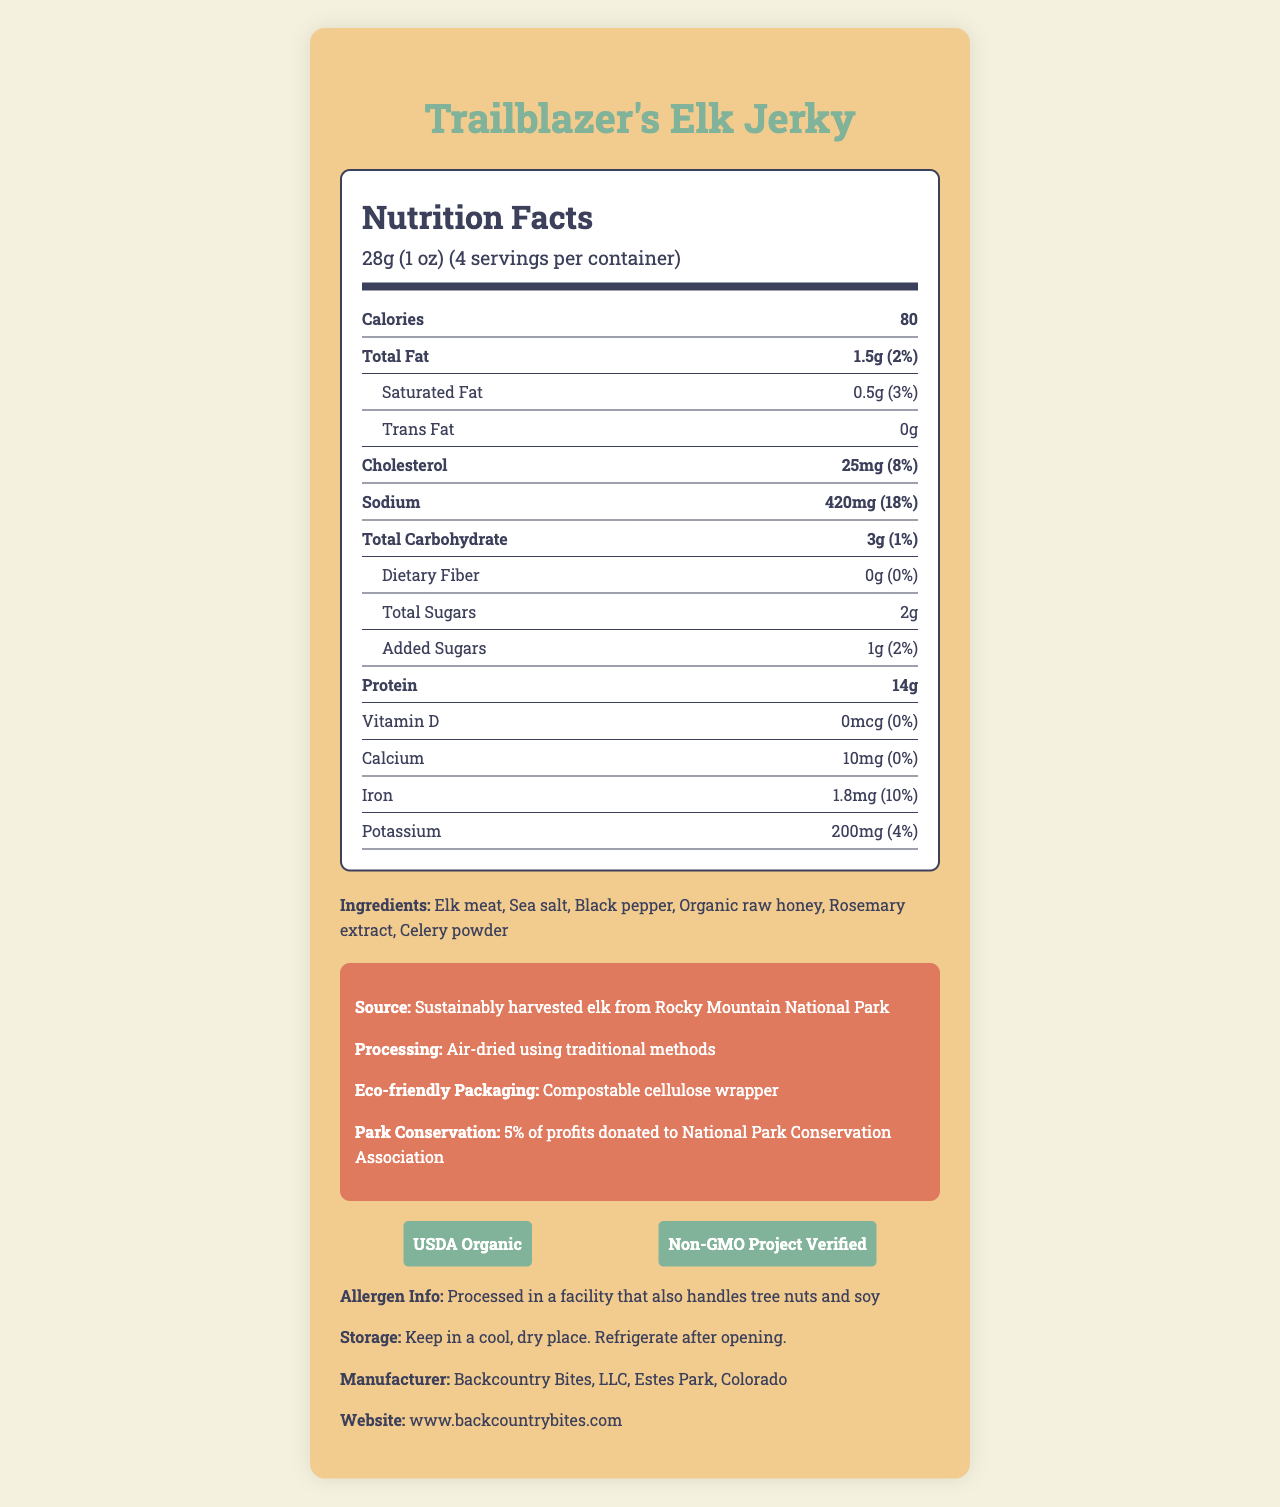What is the serving size for Trailblazer's Elk Jerky? The serving size is indicated in the "Nutrition Facts" section at the top of the label.
Answer: 28g (1 oz) How many calories are in one serving of Trailblazer's Elk Jerky? The number of calories per serving is listed clearly under the "Calories" section.
Answer: 80 What percentage of daily sodium intake does one serving of the jerky represent? This percentage is found under the "Sodium" section in the "Nutrition Facts."
Answer: 18% What is the amount of protein in one serving? The protein content per serving is listed in the "Nutrition Facts" section.
Answer: 14g Name two ingredients included in Trailblazer's Elk Jerky. Ingredients are listed at the end of the "Nutrition Facts" section.
Answer: Elk meat, Sea salt How many servings per container are there? A. 2 B. 4 C. 6 D. 8 The container holds 4 servings, as indicated in the serving size section.
Answer: B Which of the following certifications does Trailblazer's Elk Jerky have? i. USDA Organic ii. Fair Trade iii. Non-GMO Project Verified The jerky is certified USDA Organic and Non-GMO Project Verified, as mentioned in the additional info section.
Answer: i, iii Is there any Vitamin D in Trailblazer's Elk Jerky? Yes/No The Vitamin D amount is listed as 0mcg in the nutrition facts.
Answer: No Summarize what you learn from the additional info about Trailblazer's Elk Jerky. The additional info section provides details about the source, processing method, eco-friendly packaging, and conservation efforts associated with the product.
Answer: The jerky is sourced from sustainably harvested elk from Rocky Mountain National Park, air-dried using traditional methods, and has eco-friendly packaging. Additionally, 5% of profits are donated to the National Park Conservation Association. What are the storage instructions for Trailblazer's Elk Jerky? The storage instructions are located towards the end of the document.
Answer: Keep in a cool, dry place. Refrigerate after opening. Based on the nutrition label, how much dietary fiber does one serving of Trailblazer's Elk Jerky contain? The dietary fiber content is listed as 0g in the nutrition facts section.
Answer: 0g What is the purpose of the phosphorus in the jerky? The document does not mention phosphorus or its purposes.
Answer: Not enough information Who manufactures Trailblazer's Elk Jerky? The manufacturer is listed towards the end of the document, along with the location and website.
Answer: Backcountry Bites, LLC What is the total amount of sugars, including added sugars, in one serving? A. 1g B. 2g C. 3g D. 4g The total sugar content is 2g, which includes 1g of added sugars. The breakdown is listed under the "total sugars" and "added sugars" sections.
Answer: B 